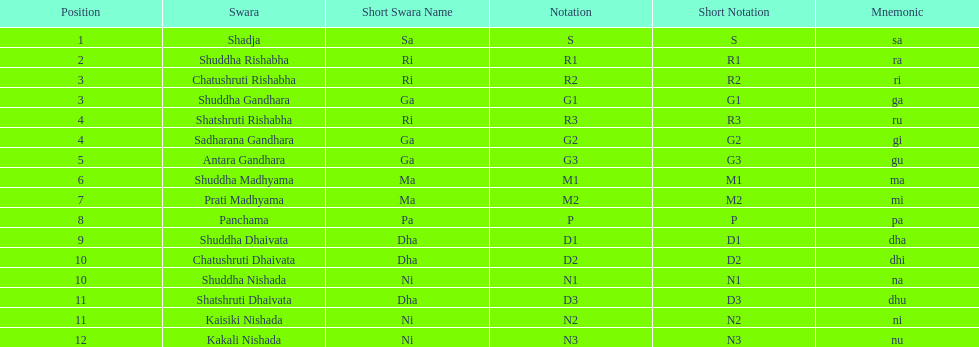What is the total number of positions listed? 16. 